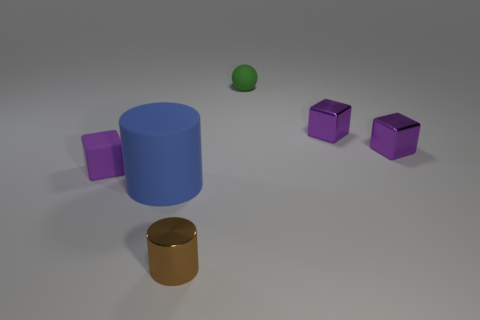Subtract all tiny purple rubber cubes. How many cubes are left? 2 Subtract all spheres. How many objects are left? 5 Subtract all brown cylinders. How many cylinders are left? 1 Add 2 large gray things. How many objects exist? 8 Subtract 1 brown cylinders. How many objects are left? 5 Subtract 1 cylinders. How many cylinders are left? 1 Subtract all brown cylinders. Subtract all gray balls. How many cylinders are left? 1 Subtract all green balls. How many brown cylinders are left? 1 Subtract all small green rubber cylinders. Subtract all large blue things. How many objects are left? 5 Add 1 tiny matte blocks. How many tiny matte blocks are left? 2 